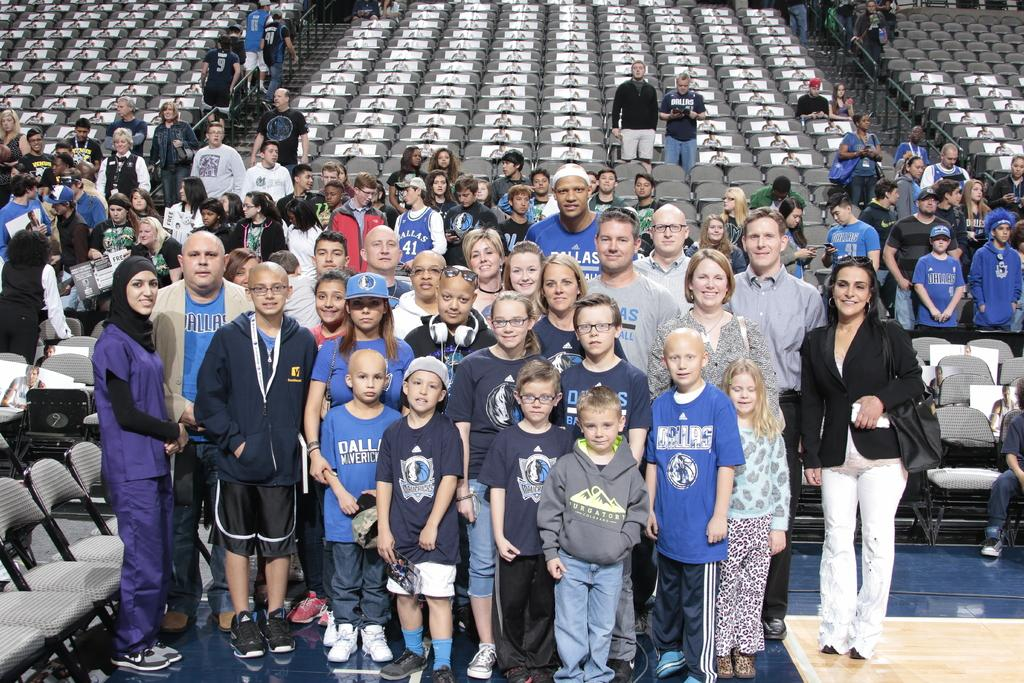What is happening in the middle of the image? There are people standing in the middle of the image. How are the people in the image feeling? The people are smiling in the image. What can be seen behind the people in the image? There are chairs visible behind the people. What type of roof can be seen in the image? There is no roof visible in the image. How is the sky depicted in the image? The sky is not depicted in the image; only the people and chairs are visible. 